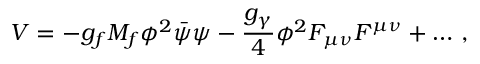<formula> <loc_0><loc_0><loc_500><loc_500>V = - g _ { f } M _ { f } \phi ^ { 2 } \bar { \psi } \psi - \frac { g _ { \gamma } } { 4 } \phi ^ { 2 } F _ { \mu \nu } F ^ { \mu \nu } + \dots \, ,</formula> 